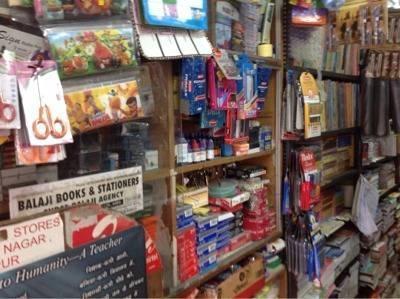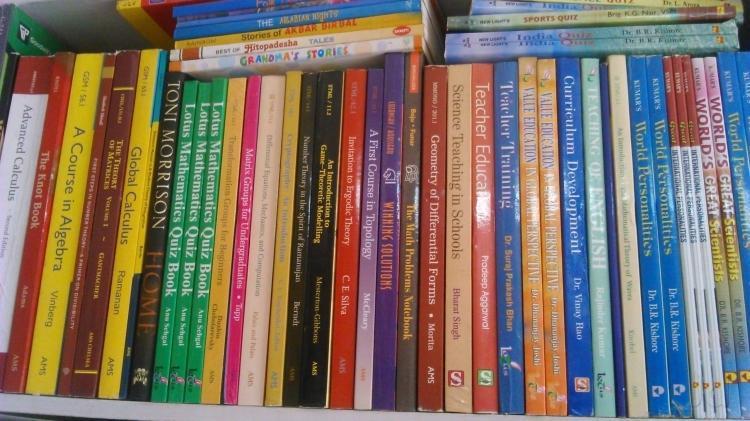The first image is the image on the left, the second image is the image on the right. Considering the images on both sides, is "Black wires can be seen in one of the images." valid? Answer yes or no. No. The first image is the image on the left, the second image is the image on the right. Evaluate the accuracy of this statement regarding the images: "One of the images is of writing supplies, hanging on a wall.". Is it true? Answer yes or no. Yes. 